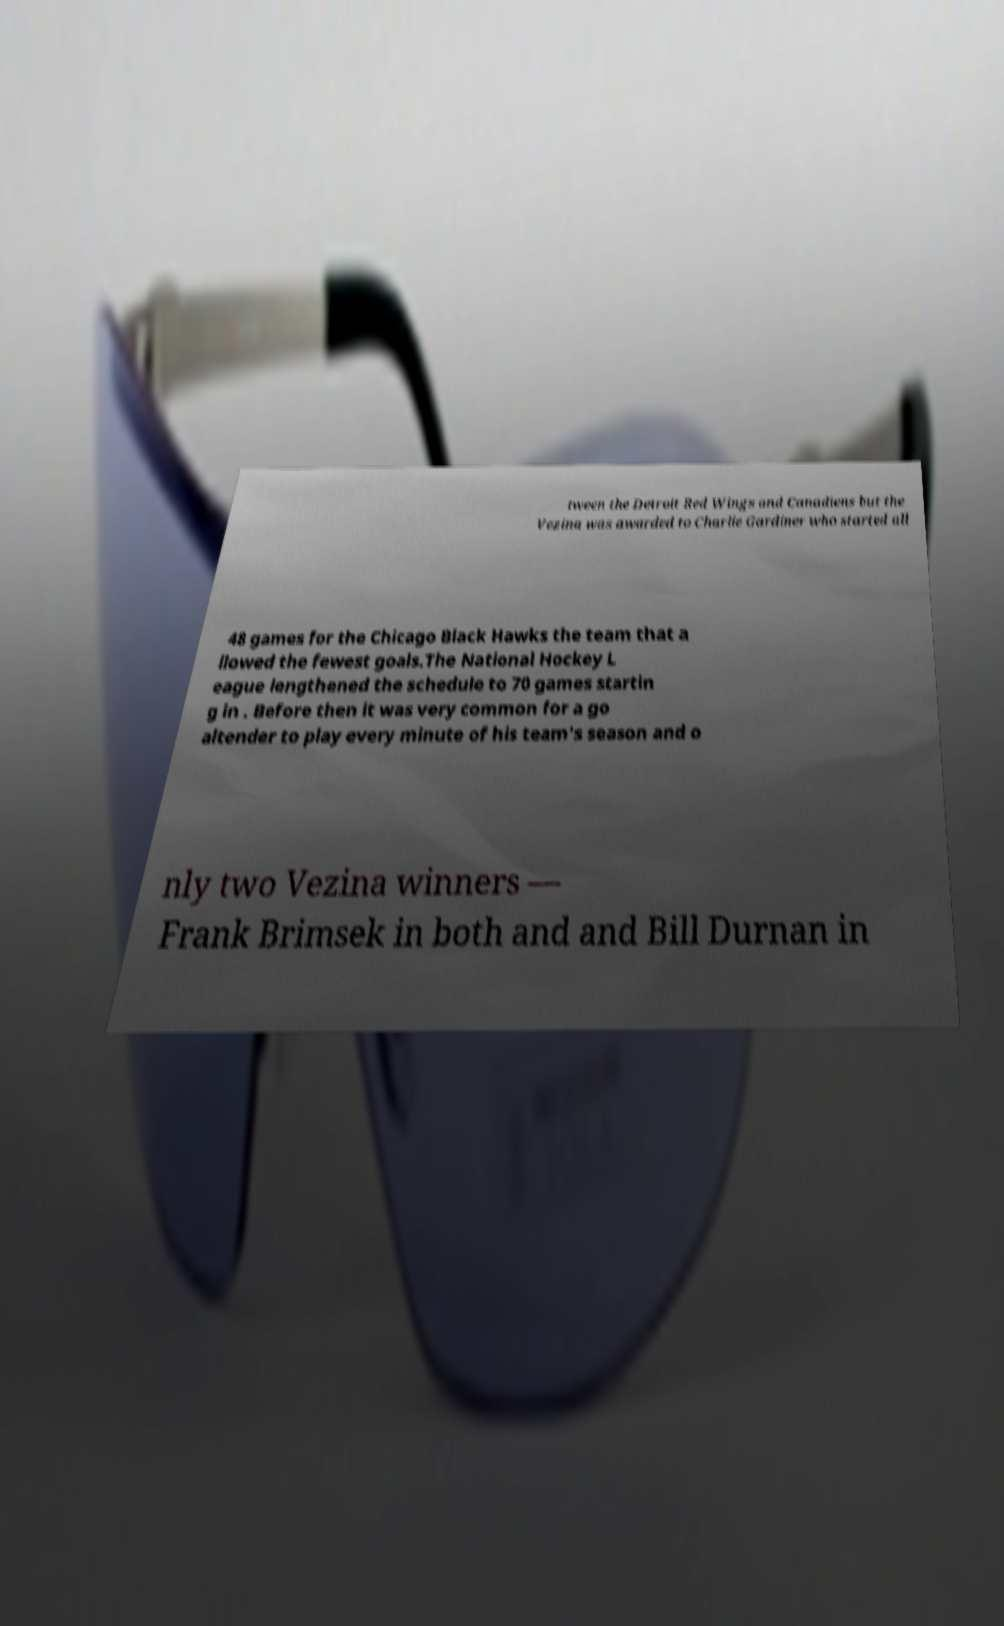What messages or text are displayed in this image? I need them in a readable, typed format. tween the Detroit Red Wings and Canadiens but the Vezina was awarded to Charlie Gardiner who started all 48 games for the Chicago Black Hawks the team that a llowed the fewest goals.The National Hockey L eague lengthened the schedule to 70 games startin g in . Before then it was very common for a go altender to play every minute of his team's season and o nly two Vezina winners — Frank Brimsek in both and and Bill Durnan in 